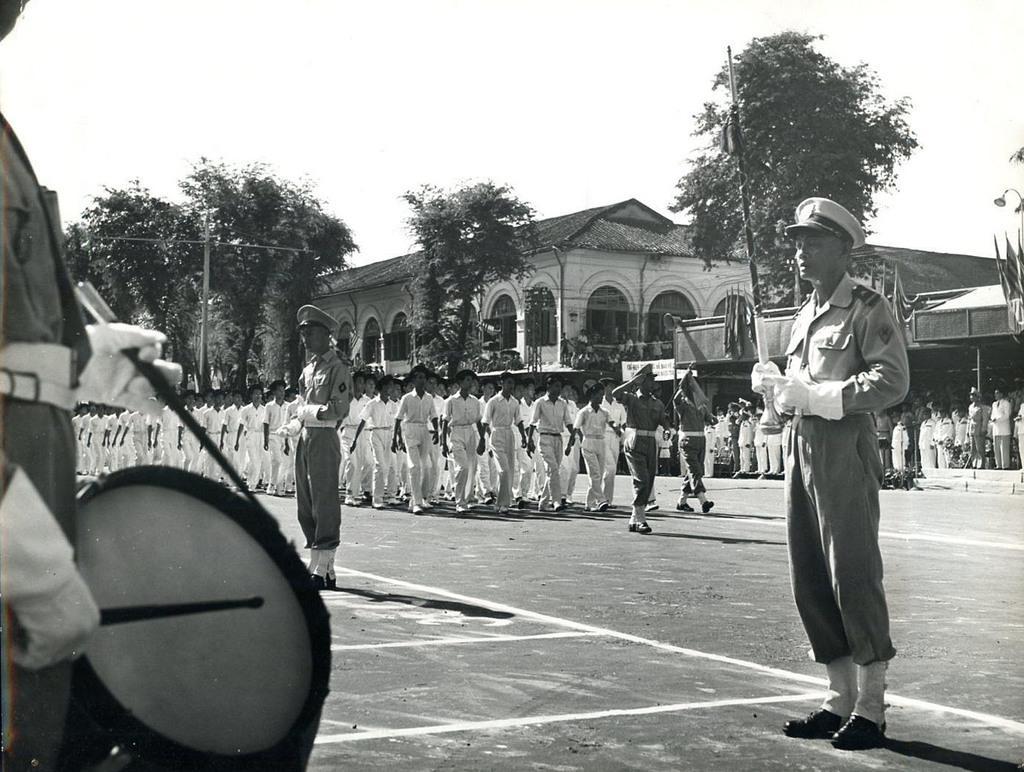Please provide a concise description of this image. a parade is going on on the road. at the left 2 people are standing wearing police uniform. at the left a person is playing drums. people performing parade are wearing white uniform. at the right people are standing and watching them. at the back there are trees, poles and buildings. 